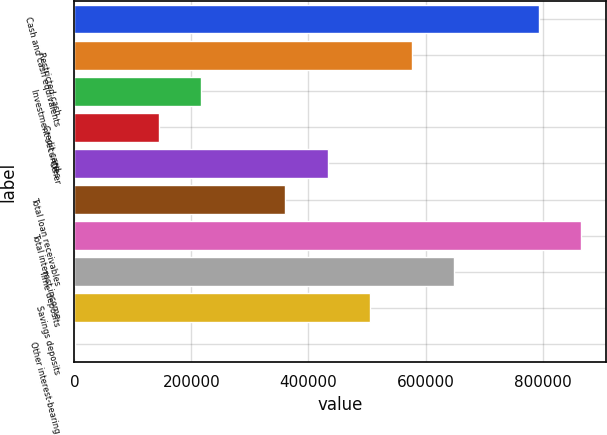Convert chart. <chart><loc_0><loc_0><loc_500><loc_500><bar_chart><fcel>Cash and cash equivalents<fcel>Restricted cash<fcel>Investment securities<fcel>Credit card<fcel>Other<fcel>Total loan receivables<fcel>Total interest income<fcel>Time deposits<fcel>Savings deposits<fcel>Other interest-bearing<nl><fcel>793170<fcel>576894<fcel>216433<fcel>144341<fcel>432710<fcel>360618<fcel>865262<fcel>648986<fcel>504802<fcel>157<nl></chart> 